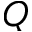<formula> <loc_0><loc_0><loc_500><loc_500>Q</formula> 